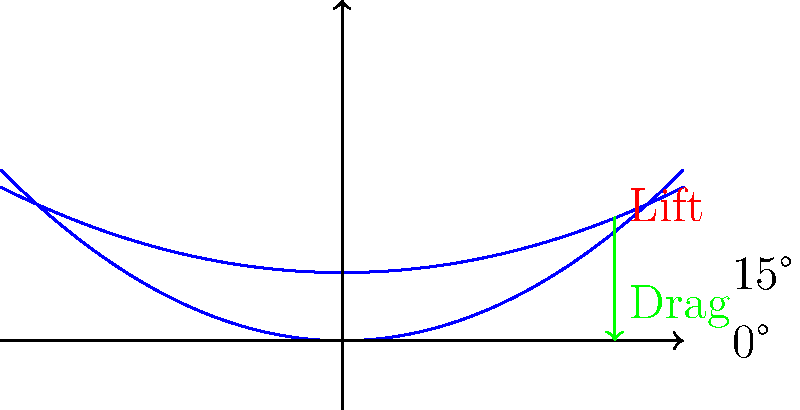In the context of airfoil performance, how does the relationship between lift and drag change as the angle of attack increases from 0° to 15°? Relate your answer to how this might impact the branding strategy for a reality show featuring aviation challenges. To answer this question, let's break down the key concepts and their implications:

1. Angle of Attack (AoA): This is the angle between the chord line of an airfoil and the direction of the oncoming air flow.

2. Lift: The upward force generated by the airfoil, perpendicular to the direction of air flow.

3. Drag: The force that opposes the motion of the airfoil through the air, parallel to the direction of air flow.

4. As the AoA increases from 0° to 15°:
   a) Lift increases: The pressure difference between the upper and lower surfaces of the airfoil becomes more pronounced.
   b) Drag also increases: Due to increased frontal area and flow separation.

5. The ratio of lift to drag (L/D ratio) initially improves as AoA increases from 0°, reaches a maximum at an optimal angle, then decreases as AoA continues to increase.

6. At 15° AoA, both lift and drag are significantly higher than at 0°, but the increase in drag is proportionally larger.

Relating to a reality show branding strategy:
- The concept of "optimal performance" (best L/D ratio) could be used to create challenges that test contestants' ability to find the perfect balance.
- The increasing difficulty and risk as AoA increases could be used to create tension and excitement in the show's narrative.
- The visual representation of lift and drag forces could be used in the show's graphics to explain complex concepts to the audience in an engaging way.
Answer: As AoA increases, both lift and drag increase, with drag increasing more rapidly, potentially symbolizing increasing challenge and risk in an aviation-themed reality show. 